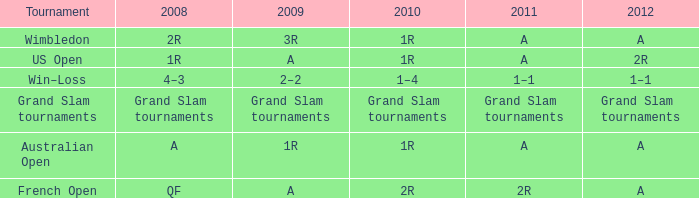Name the 2010 for 2011 of a and 2008 of 1r 1R. 